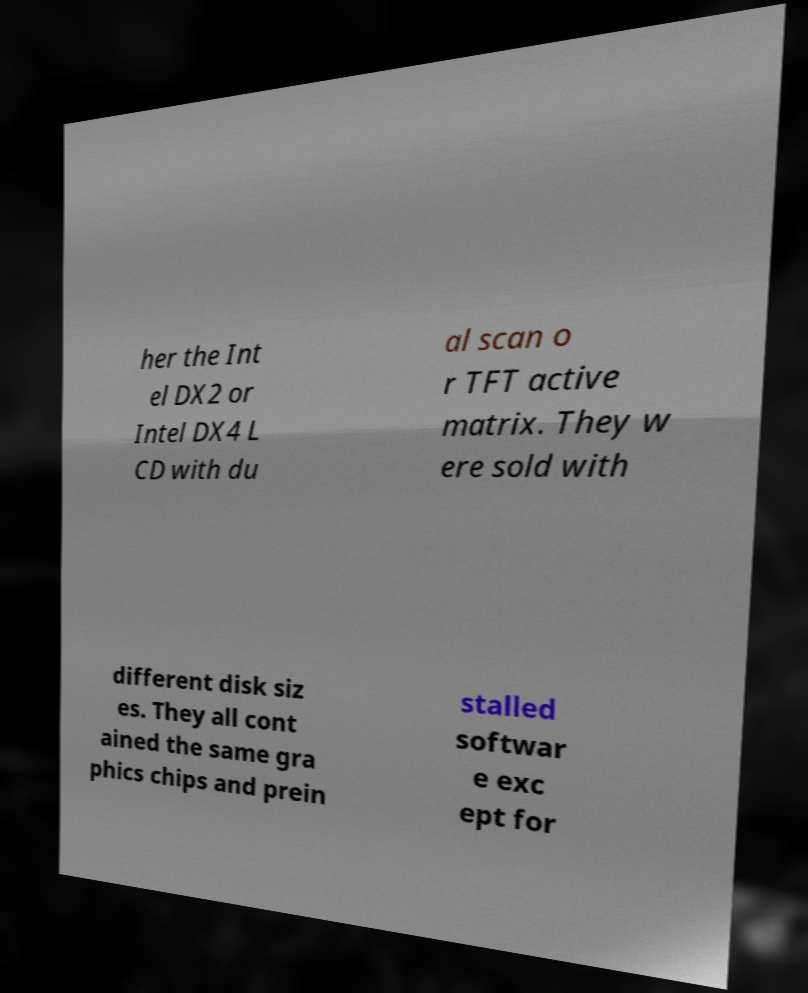There's text embedded in this image that I need extracted. Can you transcribe it verbatim? her the Int el DX2 or Intel DX4 L CD with du al scan o r TFT active matrix. They w ere sold with different disk siz es. They all cont ained the same gra phics chips and prein stalled softwar e exc ept for 